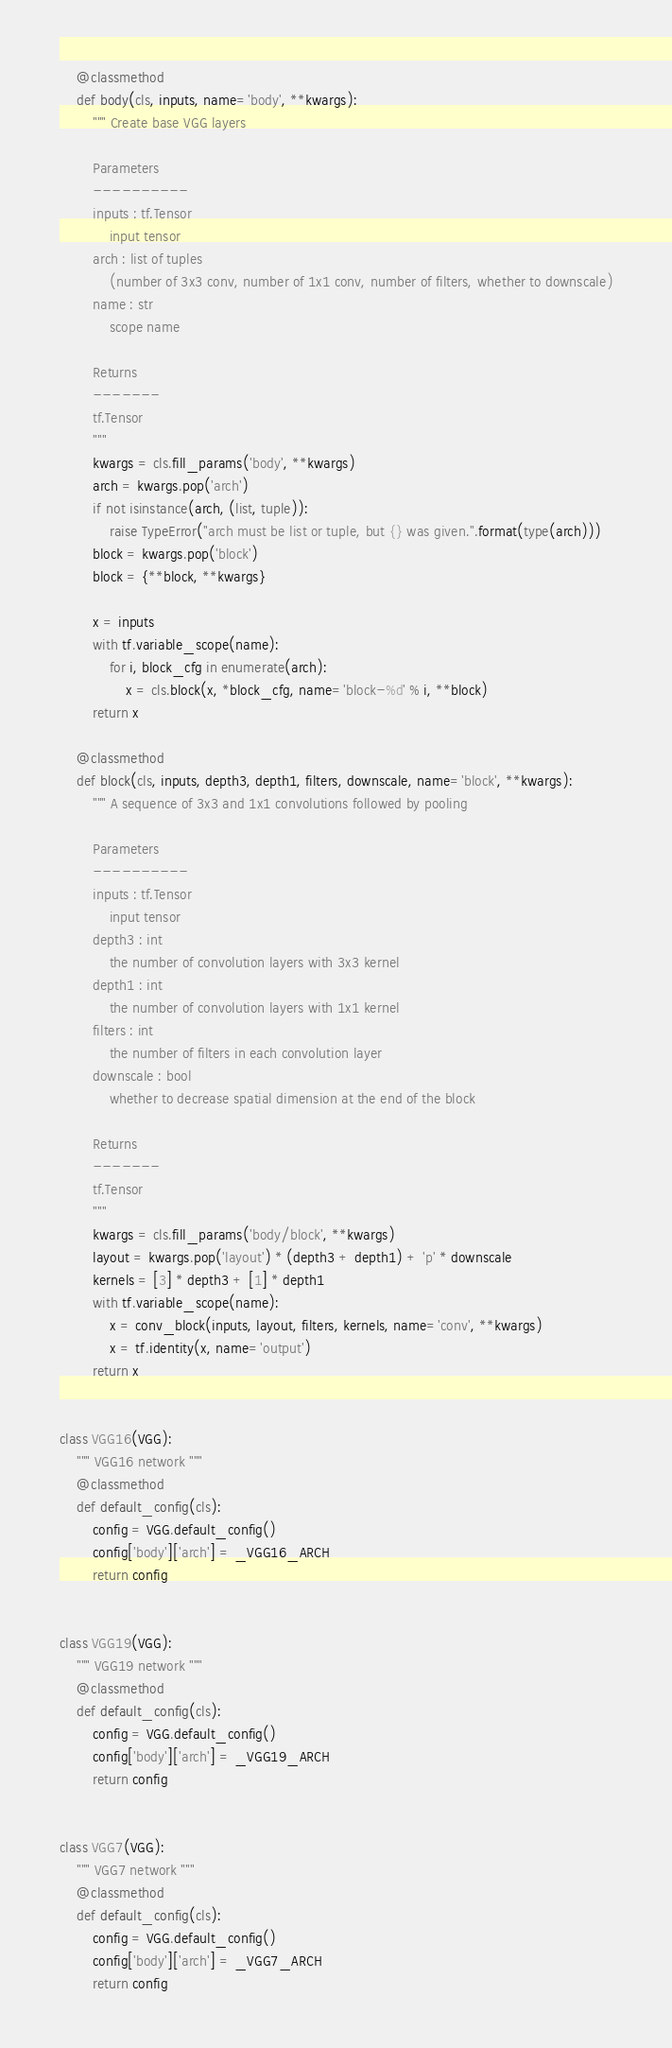Convert code to text. <code><loc_0><loc_0><loc_500><loc_500><_Python_>    @classmethod
    def body(cls, inputs, name='body', **kwargs):
        """ Create base VGG layers

        Parameters
        ----------
        inputs : tf.Tensor
            input tensor
        arch : list of tuples
            (number of 3x3 conv, number of 1x1 conv, number of filters, whether to downscale)
        name : str
            scope name

        Returns
        -------
        tf.Tensor
        """
        kwargs = cls.fill_params('body', **kwargs)
        arch = kwargs.pop('arch')
        if not isinstance(arch, (list, tuple)):
            raise TypeError("arch must be list or tuple, but {} was given.".format(type(arch)))
        block = kwargs.pop('block')
        block = {**block, **kwargs}

        x = inputs
        with tf.variable_scope(name):
            for i, block_cfg in enumerate(arch):
                x = cls.block(x, *block_cfg, name='block-%d' % i, **block)
        return x

    @classmethod
    def block(cls, inputs, depth3, depth1, filters, downscale, name='block', **kwargs):
        """ A sequence of 3x3 and 1x1 convolutions followed by pooling

        Parameters
        ----------
        inputs : tf.Tensor
            input tensor
        depth3 : int
            the number of convolution layers with 3x3 kernel
        depth1 : int
            the number of convolution layers with 1x1 kernel
        filters : int
            the number of filters in each convolution layer
        downscale : bool
            whether to decrease spatial dimension at the end of the block

        Returns
        -------
        tf.Tensor
        """
        kwargs = cls.fill_params('body/block', **kwargs)
        layout = kwargs.pop('layout') * (depth3 + depth1) + 'p' * downscale
        kernels = [3] * depth3 + [1] * depth1
        with tf.variable_scope(name):
            x = conv_block(inputs, layout, filters, kernels, name='conv', **kwargs)
            x = tf.identity(x, name='output')
        return x


class VGG16(VGG):
    """ VGG16 network """
    @classmethod
    def default_config(cls):
        config = VGG.default_config()
        config['body']['arch'] = _VGG16_ARCH
        return config


class VGG19(VGG):
    """ VGG19 network """
    @classmethod
    def default_config(cls):
        config = VGG.default_config()
        config['body']['arch'] = _VGG19_ARCH
        return config


class VGG7(VGG):
    """ VGG7 network """
    @classmethod
    def default_config(cls):
        config = VGG.default_config()
        config['body']['arch'] = _VGG7_ARCH
        return config
</code> 